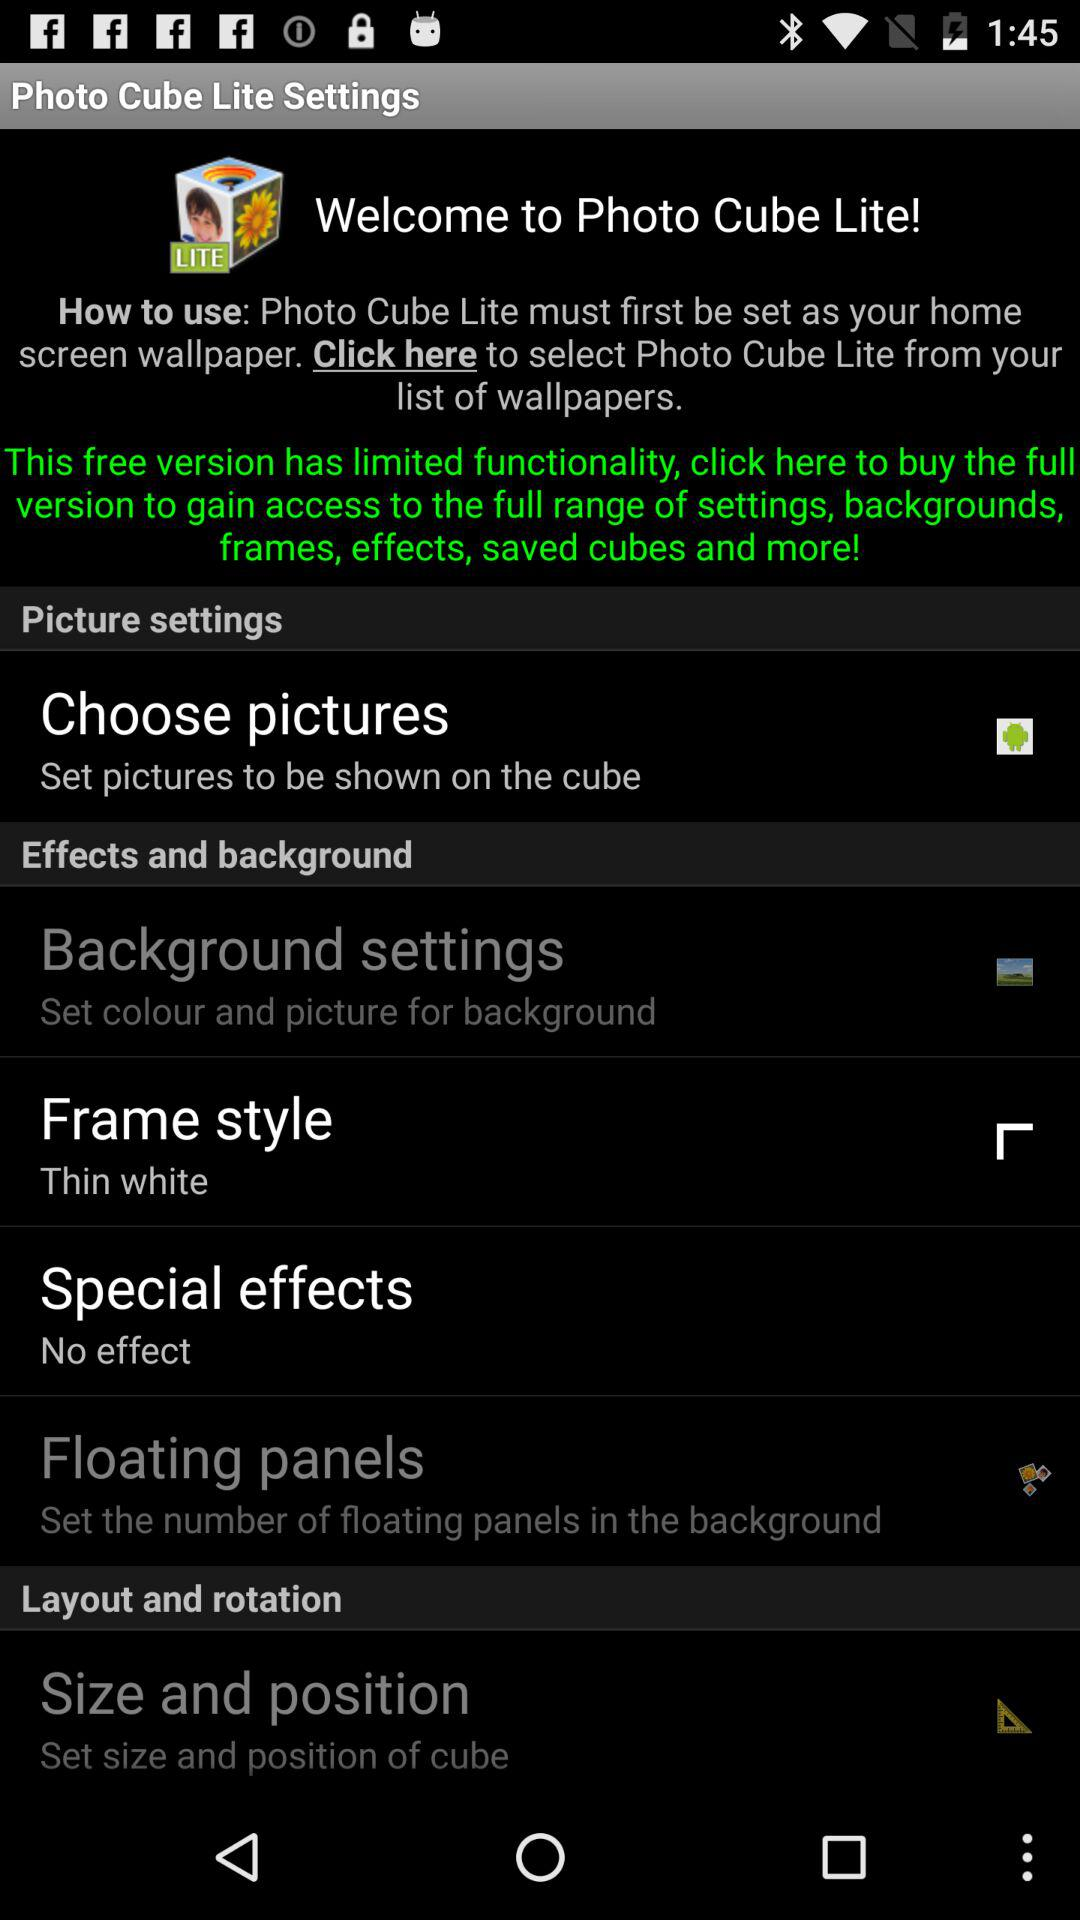What's the frame style? The frame style is "Thin white". 